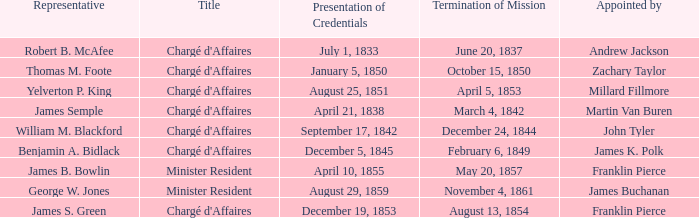Which Title has an Appointed by of Millard Fillmore? Chargé d'Affaires. Help me parse the entirety of this table. {'header': ['Representative', 'Title', 'Presentation of Credentials', 'Termination of Mission', 'Appointed by'], 'rows': [['Robert B. McAfee', "Chargé d'Affaires", 'July 1, 1833', 'June 20, 1837', 'Andrew Jackson'], ['Thomas M. Foote', "Chargé d'Affaires", 'January 5, 1850', 'October 15, 1850', 'Zachary Taylor'], ['Yelverton P. King', "Chargé d'Affaires", 'August 25, 1851', 'April 5, 1853', 'Millard Fillmore'], ['James Semple', "Chargé d'Affaires", 'April 21, 1838', 'March 4, 1842', 'Martin Van Buren'], ['William M. Blackford', "Chargé d'Affaires", 'September 17, 1842', 'December 24, 1844', 'John Tyler'], ['Benjamin A. Bidlack', "Chargé d'Affaires", 'December 5, 1845', 'February 6, 1849', 'James K. Polk'], ['James B. Bowlin', 'Minister Resident', 'April 10, 1855', 'May 20, 1857', 'Franklin Pierce'], ['George W. Jones', 'Minister Resident', 'August 29, 1859', 'November 4, 1861', 'James Buchanan'], ['James S. Green', "Chargé d'Affaires", 'December 19, 1853', 'August 13, 1854', 'Franklin Pierce']]} 